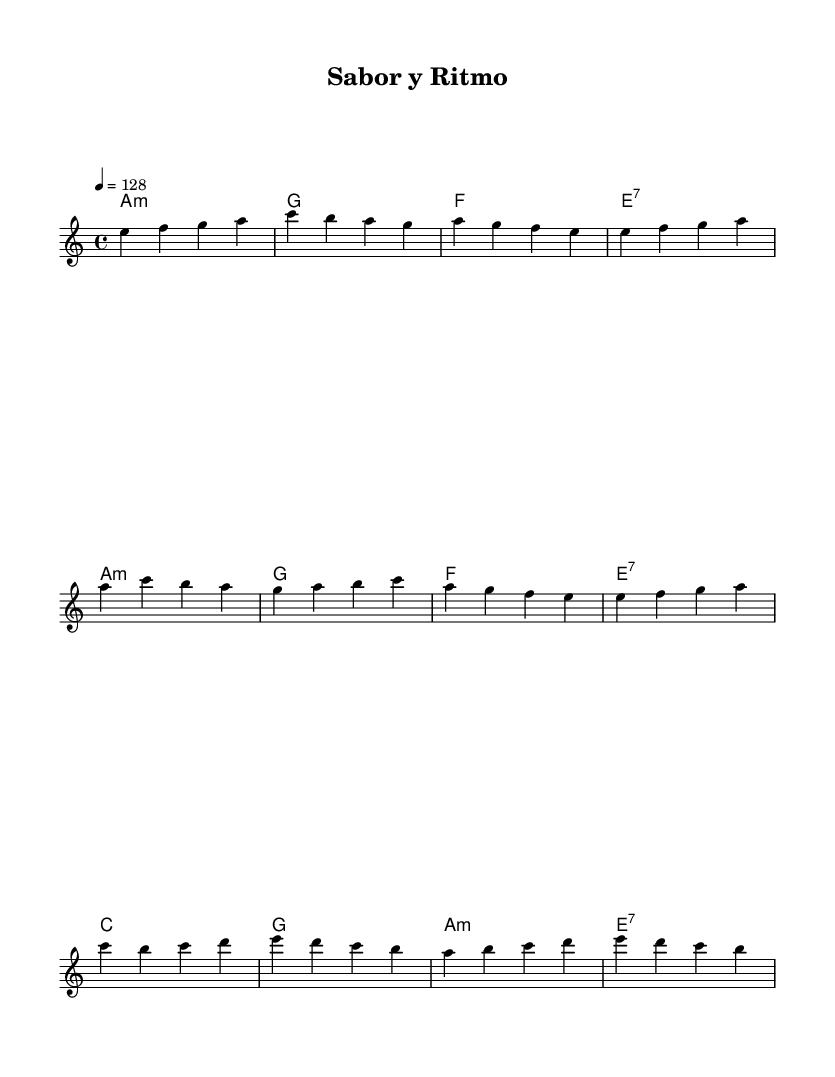What is the key signature of this music? The key signature is A minor, which contains no sharps or flats.
Answer: A minor What is the time signature of the piece? The time signature is indicated as 4/4, meaning there are four beats in a measure, and the quarter note receives one beat.
Answer: 4/4 What is the tempo marking for this composition? The tempo is marked at 128 beats per minute, indicated as 4 = 128, which signifies the speed of the piece.
Answer: 128 How many measures are in the intro section? The intro section, listed at the beginning, contains four measures with a specific melody and harmonic progression.
Answer: 4 What is the chord progression in the verse? The chords used in the verse follow the sequence of A minor, G, F, and E7, providing the harmonic foundation for this section.
Answer: A minor, G, F, E7 Which section of the music contains a chorus? The chorus section is identified distinctly after the verse and uses a different melodic and harmonic pattern.
Answer: Chorus What element makes this piece a Latin-rock fusion? The fusion element in this piece combines traditional Latin rhythms with rock instrumentation and melodic lines, creating a vibrant and energetic atmosphere suitable for a restaurant.
Answer: Latin-rock fusion 